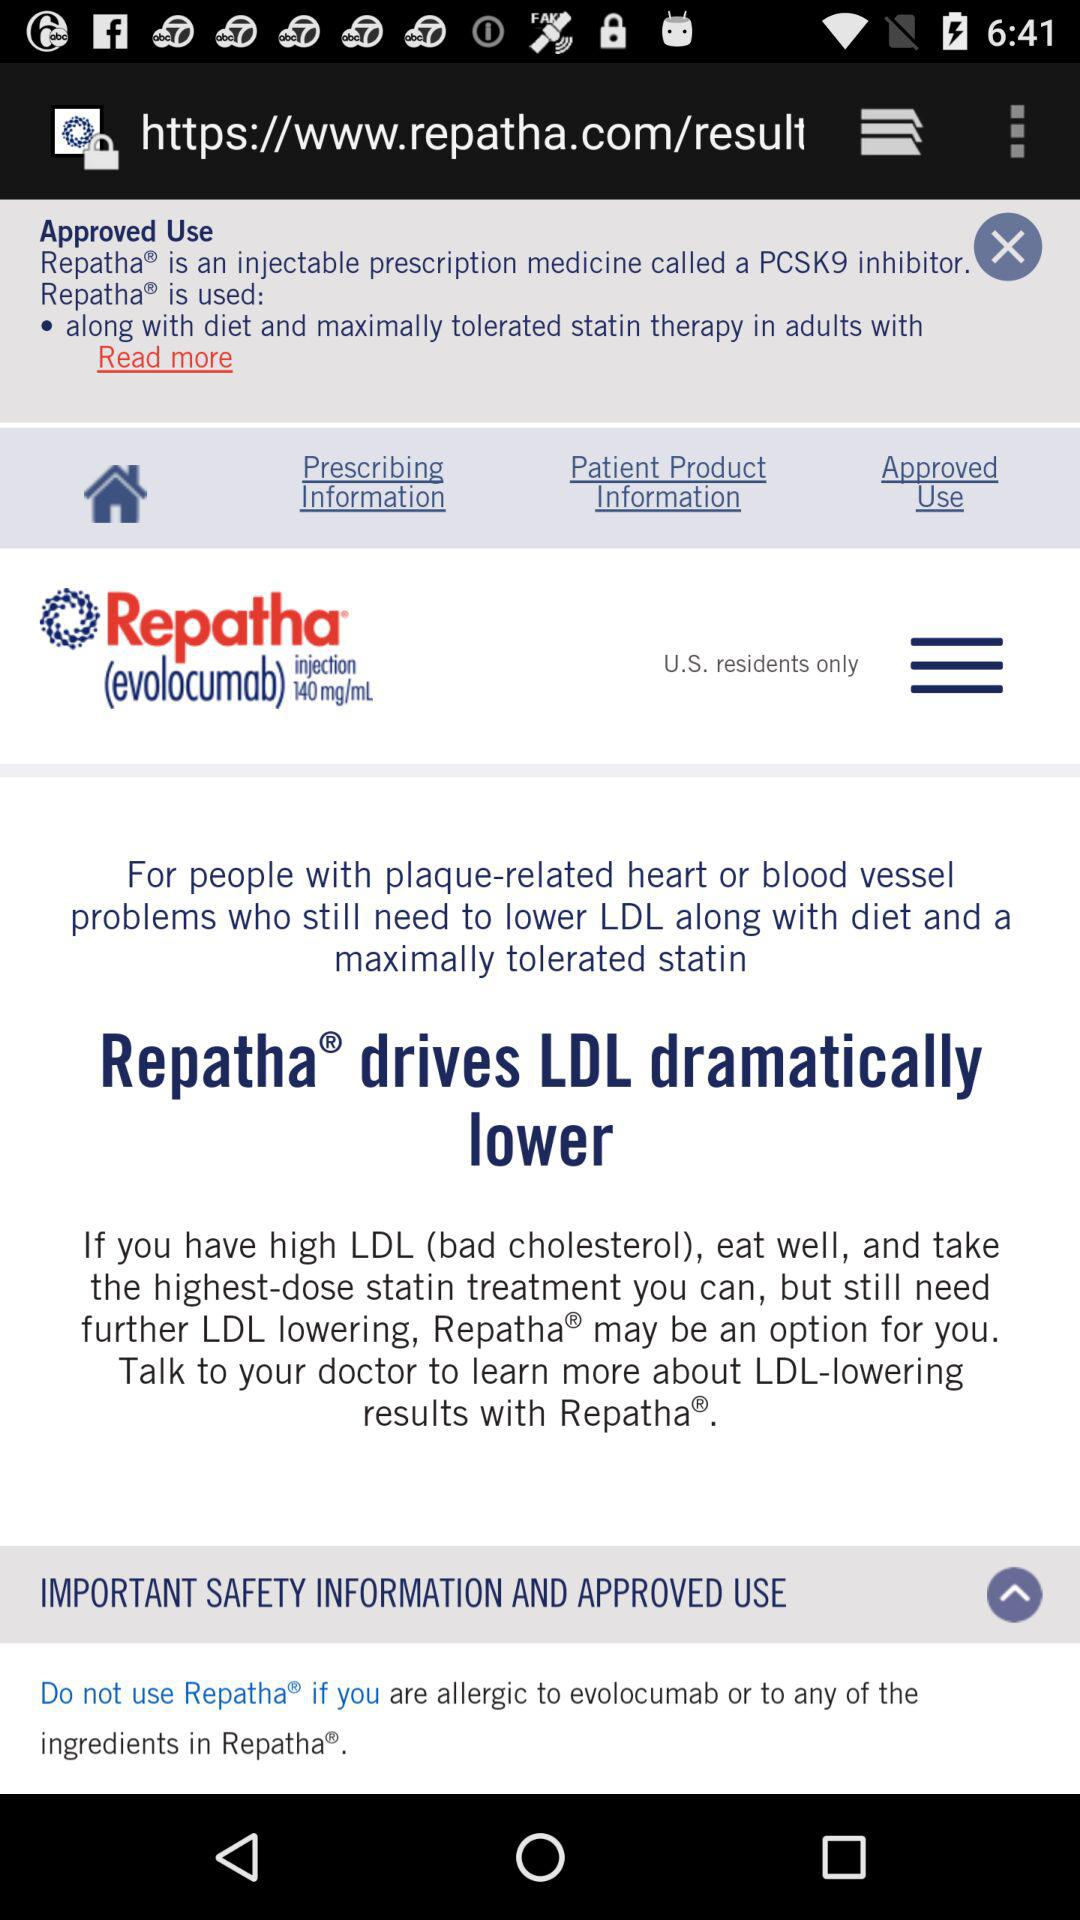What is the application name? The application name is "Repatha". 